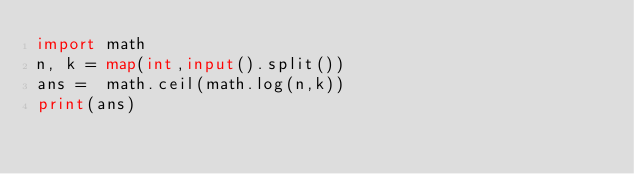<code> <loc_0><loc_0><loc_500><loc_500><_Python_>import math
n, k = map(int,input().split())
ans =  math.ceil(math.log(n,k))
print(ans)</code> 